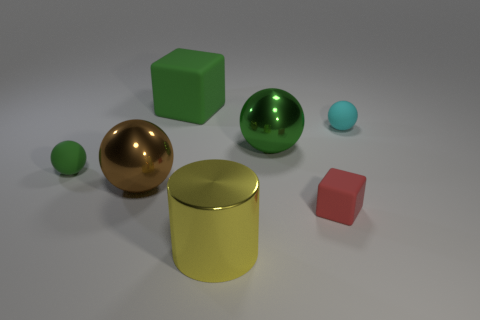Are there any green objects that have the same material as the large green ball?
Give a very brief answer. No. Do the green cube and the large green sphere have the same material?
Provide a succinct answer. No. What number of purple objects are either blocks or small rubber objects?
Provide a short and direct response. 0. Is the number of rubber objects that are to the right of the big brown shiny object greater than the number of small cyan spheres?
Keep it short and to the point. Yes. Is there another cylinder that has the same color as the cylinder?
Your answer should be compact. No. What size is the cyan matte thing?
Your answer should be very brief. Small. Do the big rubber block and the small matte block have the same color?
Your response must be concise. No. How many things are either small metal balls or small matte spheres that are in front of the cyan matte thing?
Your answer should be very brief. 1. There is a green ball that is to the left of the shiny thing in front of the tiny red rubber cube; how many tiny cyan matte objects are left of it?
Make the answer very short. 0. There is a small sphere that is the same color as the big matte block; what is its material?
Offer a very short reply. Rubber. 